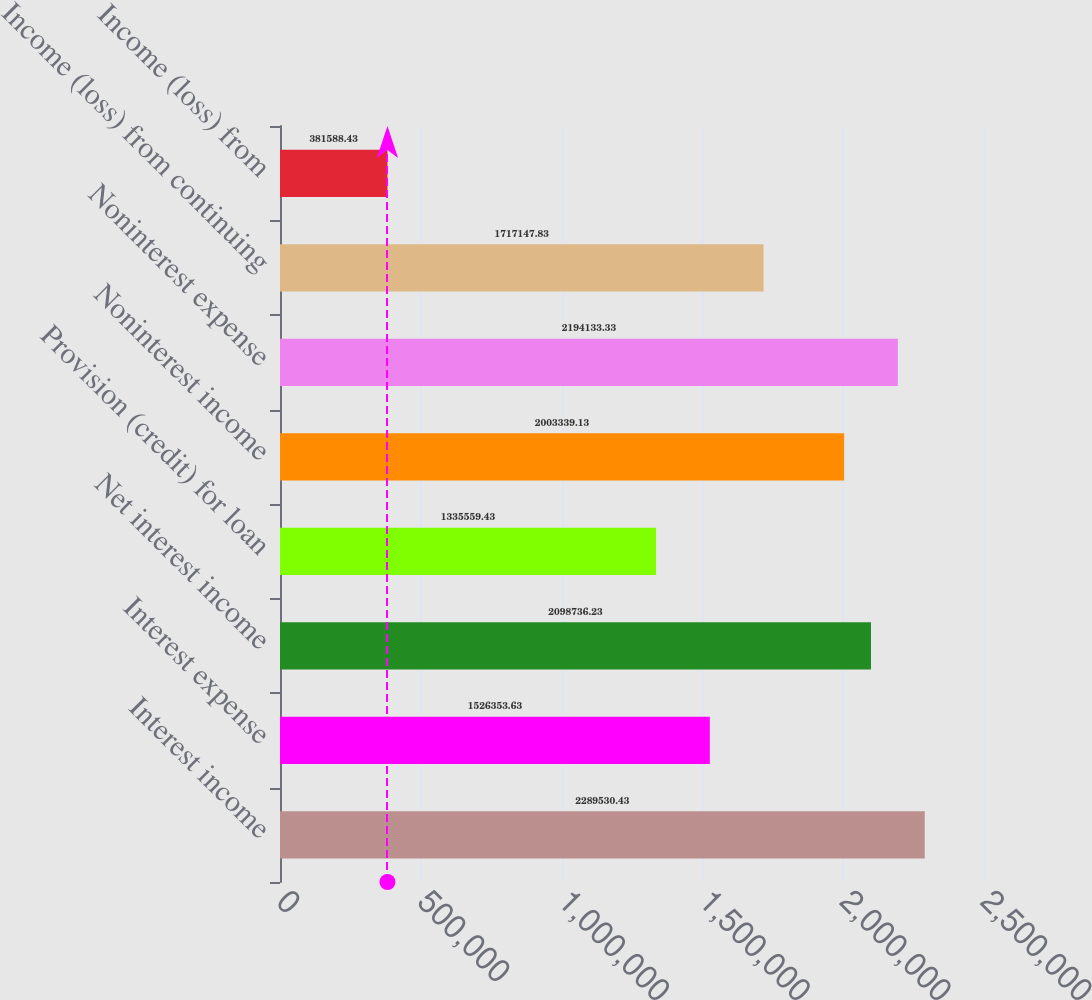Convert chart to OTSL. <chart><loc_0><loc_0><loc_500><loc_500><bar_chart><fcel>Interest income<fcel>Interest expense<fcel>Net interest income<fcel>Provision (credit) for loan<fcel>Noninterest income<fcel>Noninterest expense<fcel>Income (loss) from continuing<fcel>Income (loss) from<nl><fcel>2.28953e+06<fcel>1.52635e+06<fcel>2.09874e+06<fcel>1.33556e+06<fcel>2.00334e+06<fcel>2.19413e+06<fcel>1.71715e+06<fcel>381588<nl></chart> 